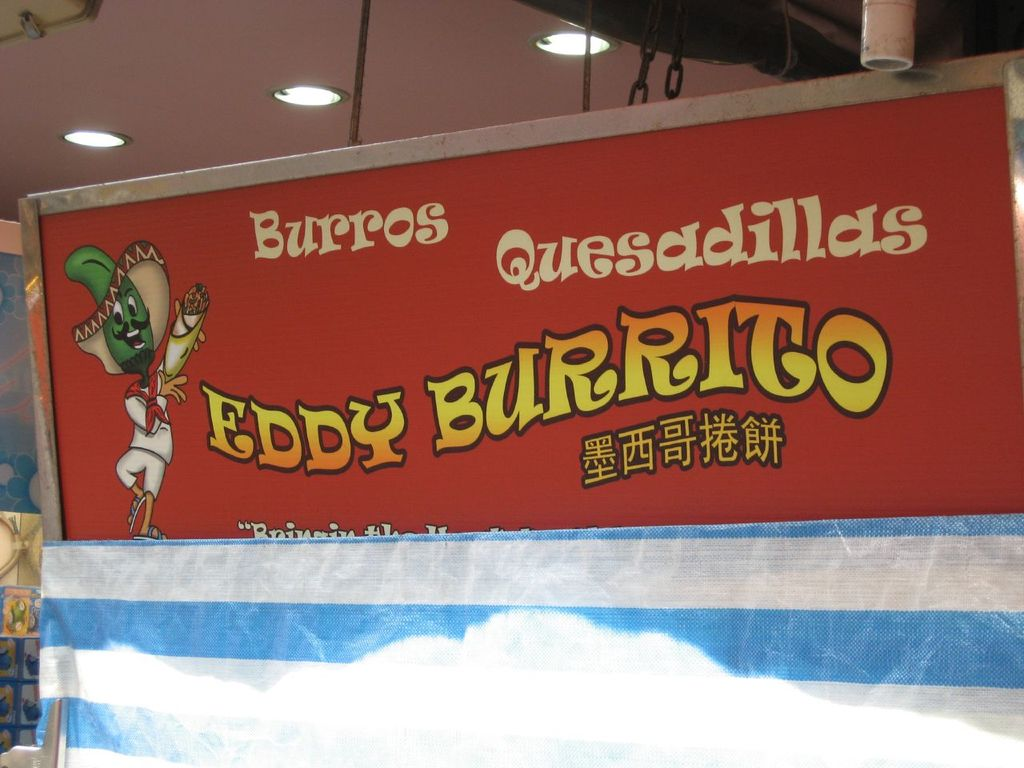What does the phrase 'Bringing the taste of Mexico to Hong Kong' on the sign suggest about the restaurant's mission? The phrase 'Bringing the taste of Mexico to Hong Kong' indicates the restaurant's goal of introducing and integrating Mexican cuisine within the local culinary landscape of Hong Kong. It suggests a commitment to providing authentic Mexican flavors, potentially tailored to suit local tastes but without compromising the essence of traditional Mexican dishes. This mission reflects a cultural exchange, aiming to expand the gastronomic diversity in Hong Kong while offering residents and visitors a taste of Mexico's rich culinary heritage. 